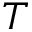Convert formula to latex. <formula><loc_0><loc_0><loc_500><loc_500>T</formula> 